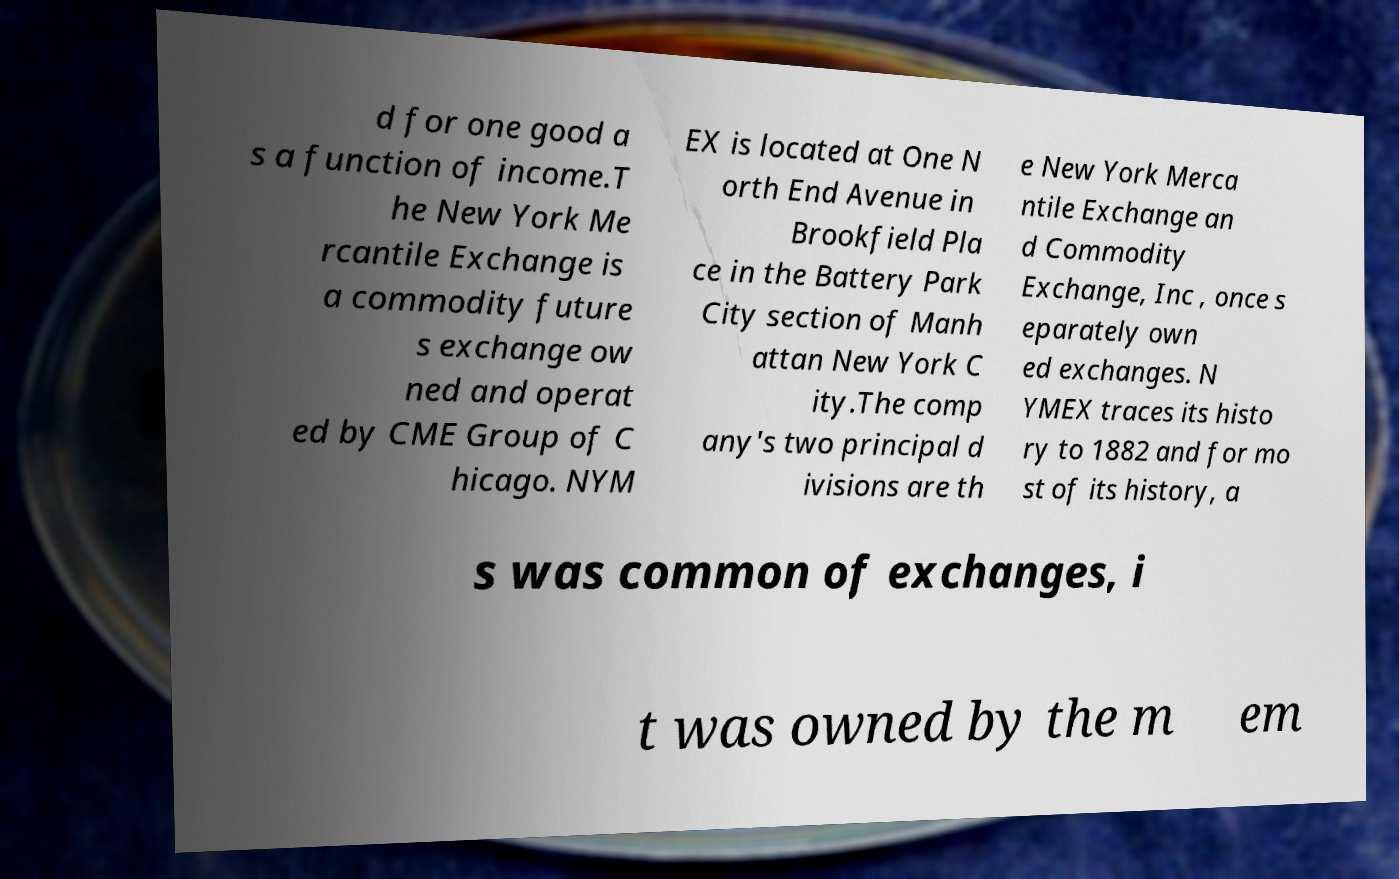Could you extract and type out the text from this image? d for one good a s a function of income.T he New York Me rcantile Exchange is a commodity future s exchange ow ned and operat ed by CME Group of C hicago. NYM EX is located at One N orth End Avenue in Brookfield Pla ce in the Battery Park City section of Manh attan New York C ity.The comp any's two principal d ivisions are th e New York Merca ntile Exchange an d Commodity Exchange, Inc , once s eparately own ed exchanges. N YMEX traces its histo ry to 1882 and for mo st of its history, a s was common of exchanges, i t was owned by the m em 